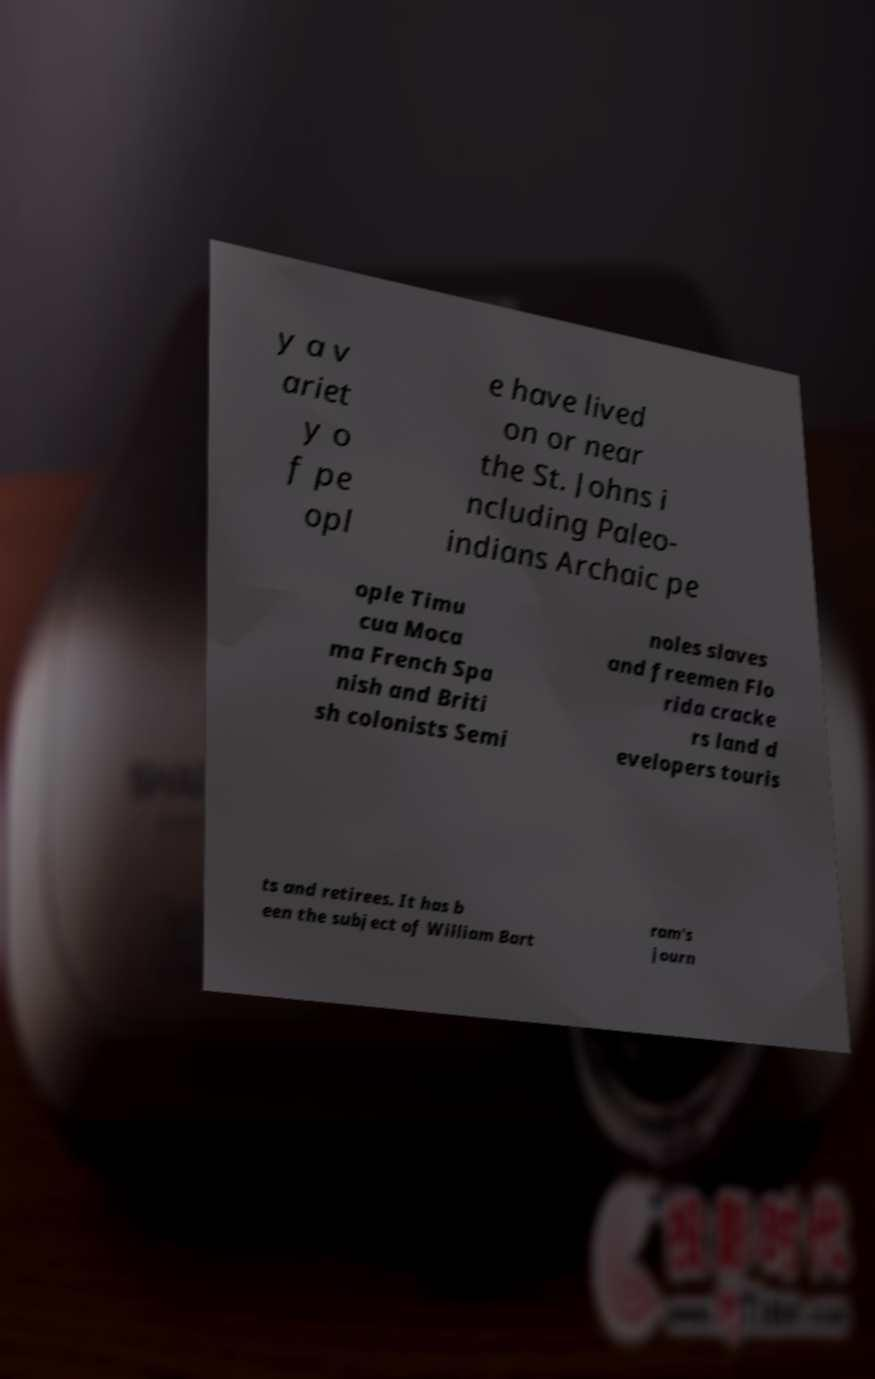Please read and relay the text visible in this image. What does it say? y a v ariet y o f pe opl e have lived on or near the St. Johns i ncluding Paleo- indians Archaic pe ople Timu cua Moca ma French Spa nish and Briti sh colonists Semi noles slaves and freemen Flo rida cracke rs land d evelopers touris ts and retirees. It has b een the subject of William Bart ram's journ 